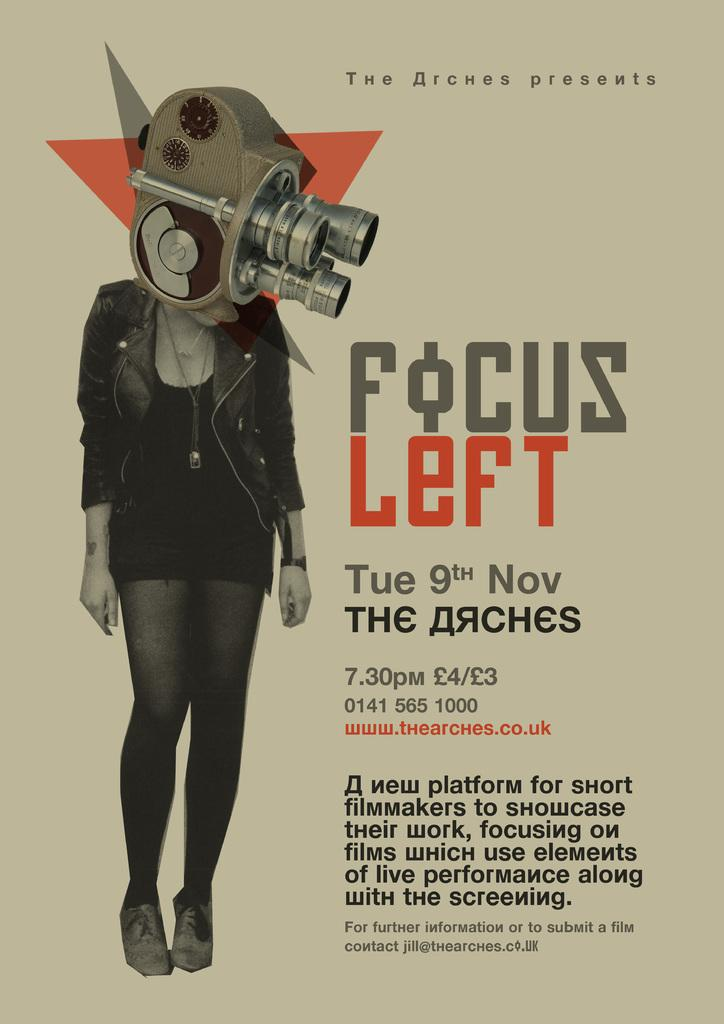<image>
Describe the image concisely. the word focus is on the poster with a lady on it 